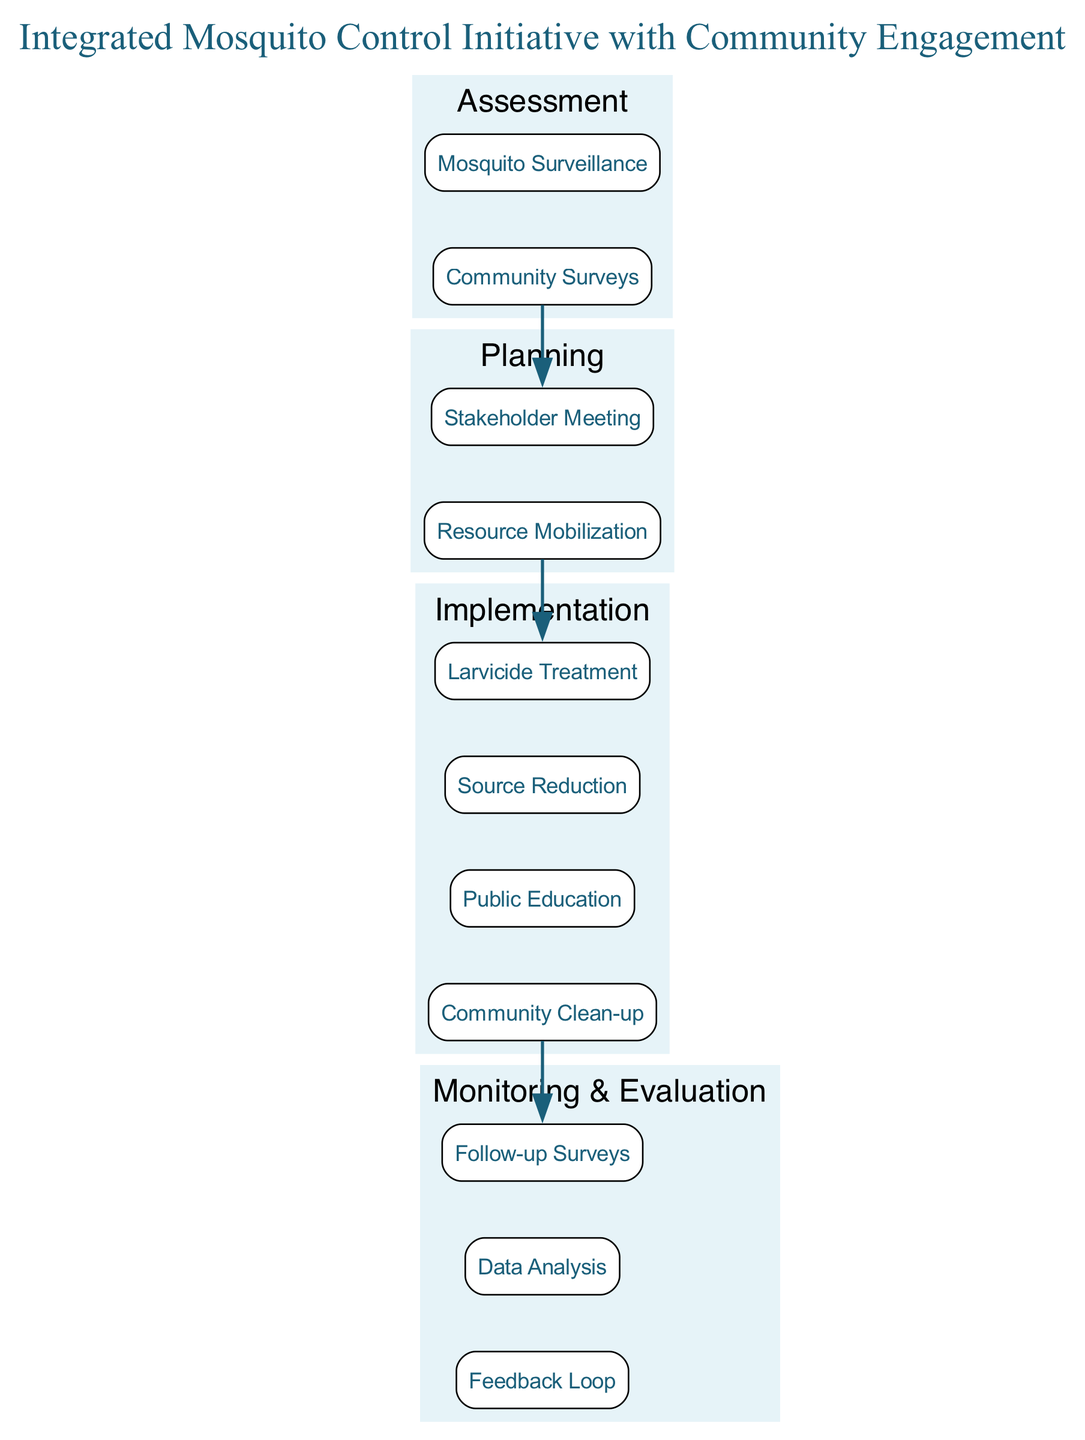What is the title of the clinical pathway? The title of the clinical pathway is prominently displayed at the top of the diagram. It reads "Integrated Mosquito Control Initiative with Community Engagement."
Answer: Integrated Mosquito Control Initiative with Community Engagement How many phases are in the pathway? The diagram lists four distinct phases: Assessment, Planning, Implementation, and Monitoring & Evaluation. Counting these, we find a total of four.
Answer: 4 What is the first element in the Assessment phase? The Assessment phase includes elements in a specific order. The first element listed is "Mosquito Surveillance."
Answer: Mosquito Surveillance Which phase follows the Planning phase? Assessing the order of phases in the diagram shows that "Implementation" comes directly after "Planning."
Answer: Implementation How many elements are in the Implementation phase? The Implementation phase is detailed with four elements listed beneath it. By counting these, we confirm there are four elements.
Answer: 4 What is the last element in the Monitoring & Evaluation phase? The last element provided in the Monitoring & Evaluation phase is "Feedback Loop." This can be identified as the name appears at the bottom of that section.
Answer: Feedback Loop Which phase involves "Resource Mobilization"? The name "Resource Mobilization" is found explicitly under the Planning phase. Therefore, this phase is where it is located.
Answer: Planning In which phase do community surveys occur? "Community Surveys" is listed as part of the assessment activities, hence it occurs during the Assessment phase.
Answer: Assessment What is the link between the Assessment and Planning phases? Examining the diagram reveals that there is a direct edge connecting the last element in the Assessment phase to the first element in the Planning phase, indicating their sequential relationship.
Answer: Direct link 